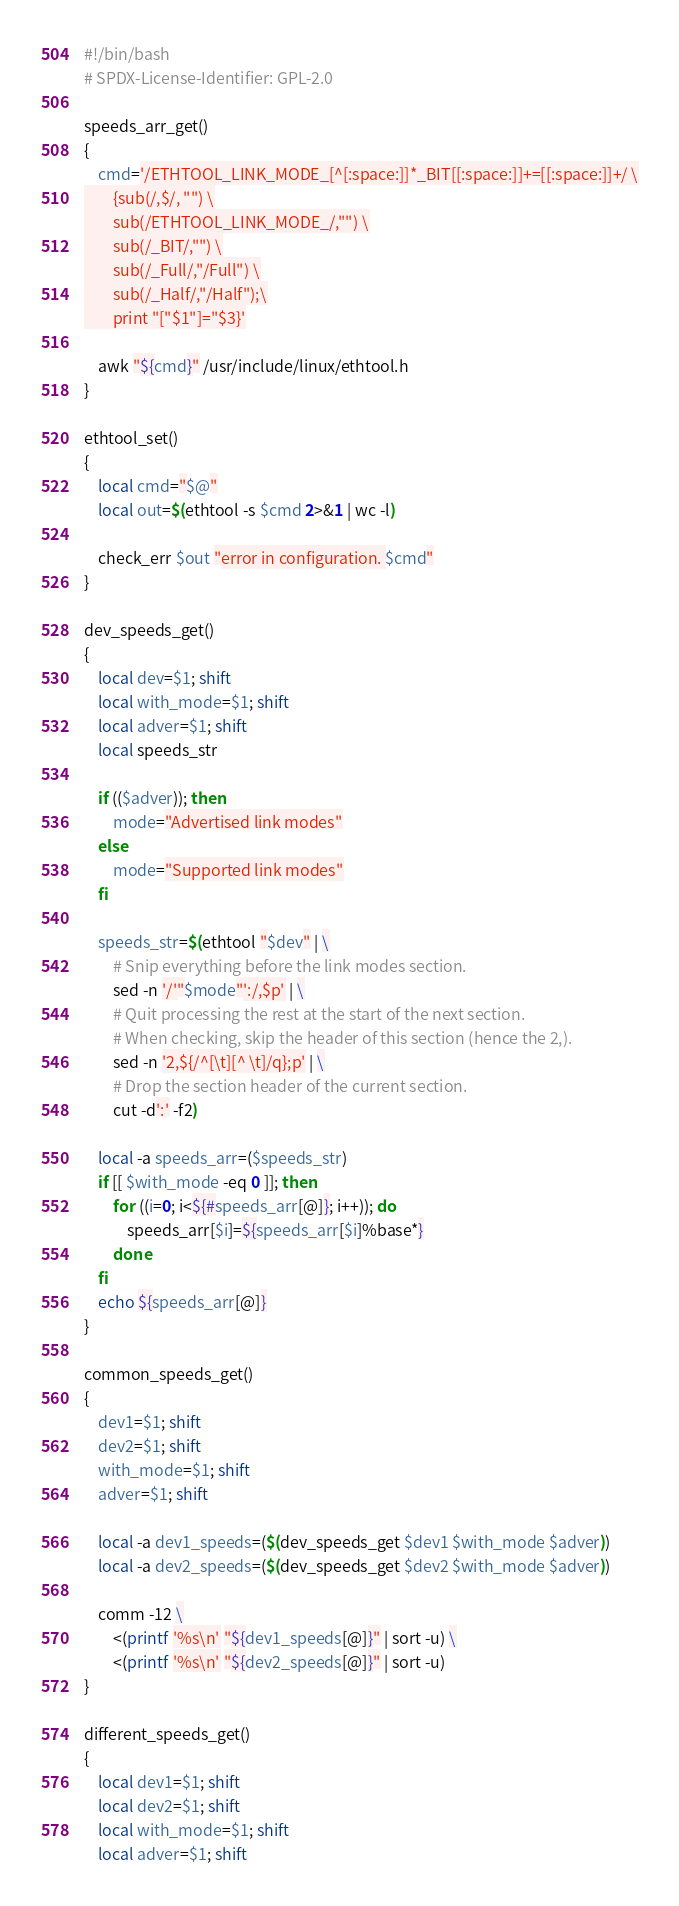<code> <loc_0><loc_0><loc_500><loc_500><_Bash_>#!/bin/bash
# SPDX-License-Identifier: GPL-2.0

speeds_arr_get()
{
	cmd='/ETHTOOL_LINK_MODE_[^[:space:]]*_BIT[[:space:]]+=[[:space:]]+/ \
		{sub(/,$/, "") \
		sub(/ETHTOOL_LINK_MODE_/,"") \
		sub(/_BIT/,"") \
		sub(/_Full/,"/Full") \
		sub(/_Half/,"/Half");\
		print "["$1"]="$3}'

	awk "${cmd}" /usr/include/linux/ethtool.h
}

ethtool_set()
{
	local cmd="$@"
	local out=$(ethtool -s $cmd 2>&1 | wc -l)

	check_err $out "error in configuration. $cmd"
}

dev_speeds_get()
{
	local dev=$1; shift
	local with_mode=$1; shift
	local adver=$1; shift
	local speeds_str

	if (($adver)); then
		mode="Advertised link modes"
	else
		mode="Supported link modes"
	fi

	speeds_str=$(ethtool "$dev" | \
		# Snip everything before the link modes section.
		sed -n '/'"$mode"':/,$p' | \
		# Quit processing the rest at the start of the next section.
		# When checking, skip the header of this section (hence the 2,).
		sed -n '2,${/^[\t][^ \t]/q};p' | \
		# Drop the section header of the current section.
		cut -d':' -f2)

	local -a speeds_arr=($speeds_str)
	if [[ $with_mode -eq 0 ]]; then
		for ((i=0; i<${#speeds_arr[@]}; i++)); do
			speeds_arr[$i]=${speeds_arr[$i]%base*}
		done
	fi
	echo ${speeds_arr[@]}
}

common_speeds_get()
{
	dev1=$1; shift
	dev2=$1; shift
	with_mode=$1; shift
	adver=$1; shift

	local -a dev1_speeds=($(dev_speeds_get $dev1 $with_mode $adver))
	local -a dev2_speeds=($(dev_speeds_get $dev2 $with_mode $adver))

	comm -12 \
		<(printf '%s\n' "${dev1_speeds[@]}" | sort -u) \
		<(printf '%s\n' "${dev2_speeds[@]}" | sort -u)
}

different_speeds_get()
{
	local dev1=$1; shift
	local dev2=$1; shift
	local with_mode=$1; shift
	local adver=$1; shift
</code> 